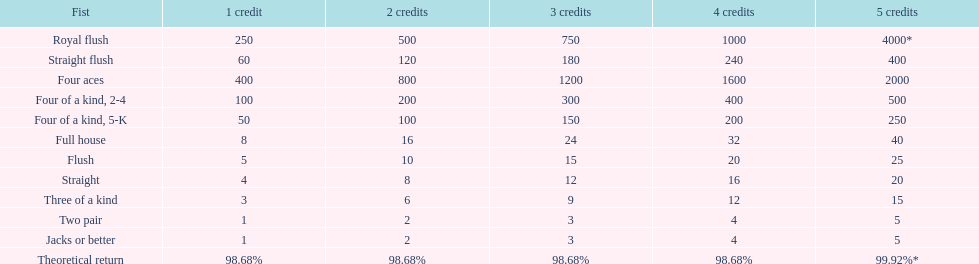At most, what could a person earn for having a full house? 40. 